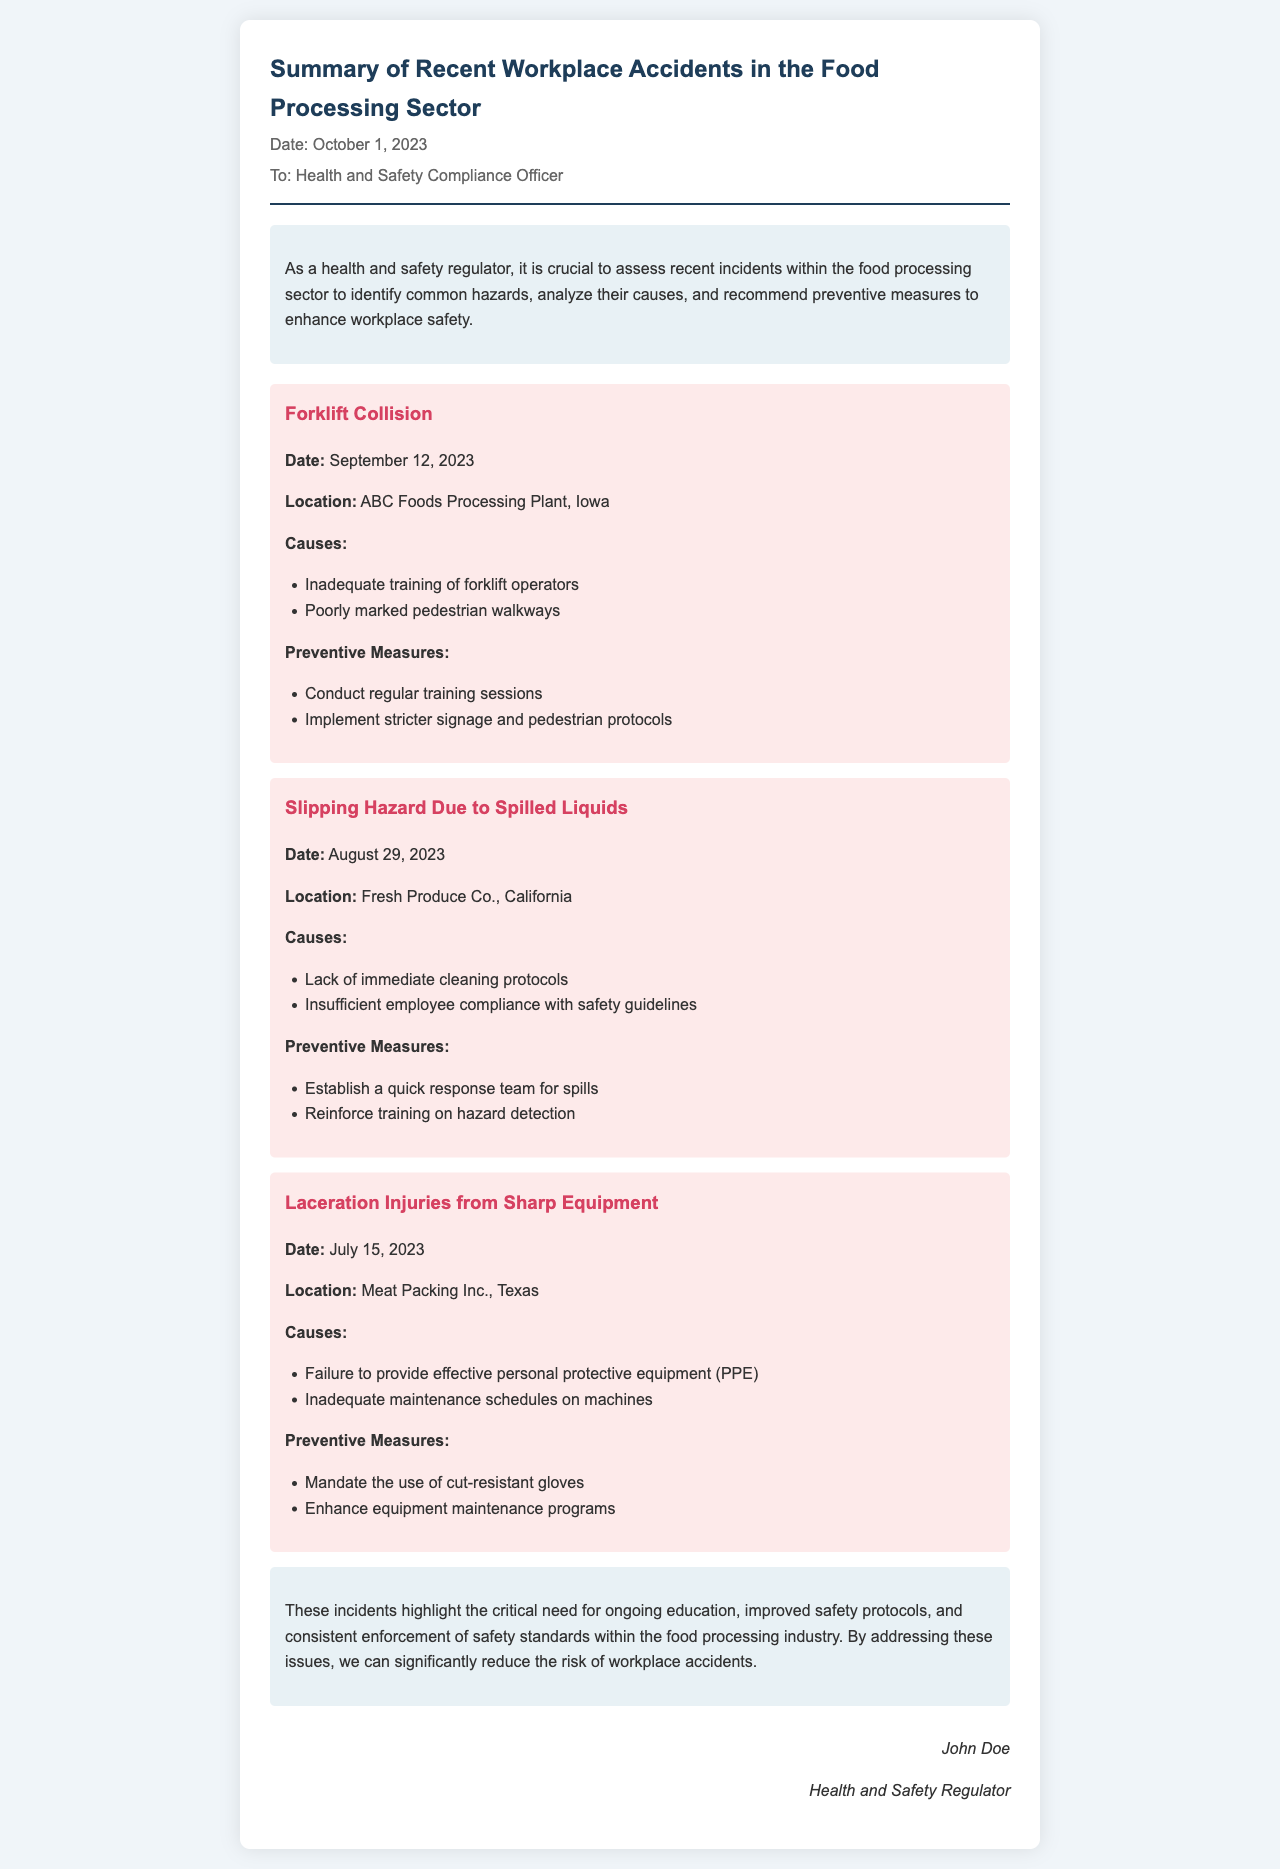What is the date of the document? The document is dated October 1, 2023, as stated in the header.
Answer: October 1, 2023 Which plant experienced a forklift collision? The accident occurred at ABC Foods Processing Plant, as mentioned in the accident details.
Answer: ABC Foods Processing Plant What was a cause of the slipping hazard incident? One of the causes listed for the slipping hazard incident was the lack of immediate cleaning protocols.
Answer: Lack of immediate cleaning protocols How many accidents are summarized in the document? The document summarizes three accidents in the food processing sector.
Answer: Three What measure is suggested to prevent laceration injuries? The document mandates the use of cut-resistant gloves as a preventive measure against laceration injuries.
Answer: Cut-resistant gloves What location is associated with the laceration injuries? The laceration injuries occurred at Meat Packing Inc., Texas, as specified in the accident report.
Answer: Meat Packing Inc., Texas What is a suggested preventive measure for the forklift collision? The document suggests conducting regular training sessions as a preventive measure for forklift collisions.
Answer: Conduct regular training sessions Who signed the document? The signature at the end of the letter indicates that John Doe is the person who signed it.
Answer: John Doe 